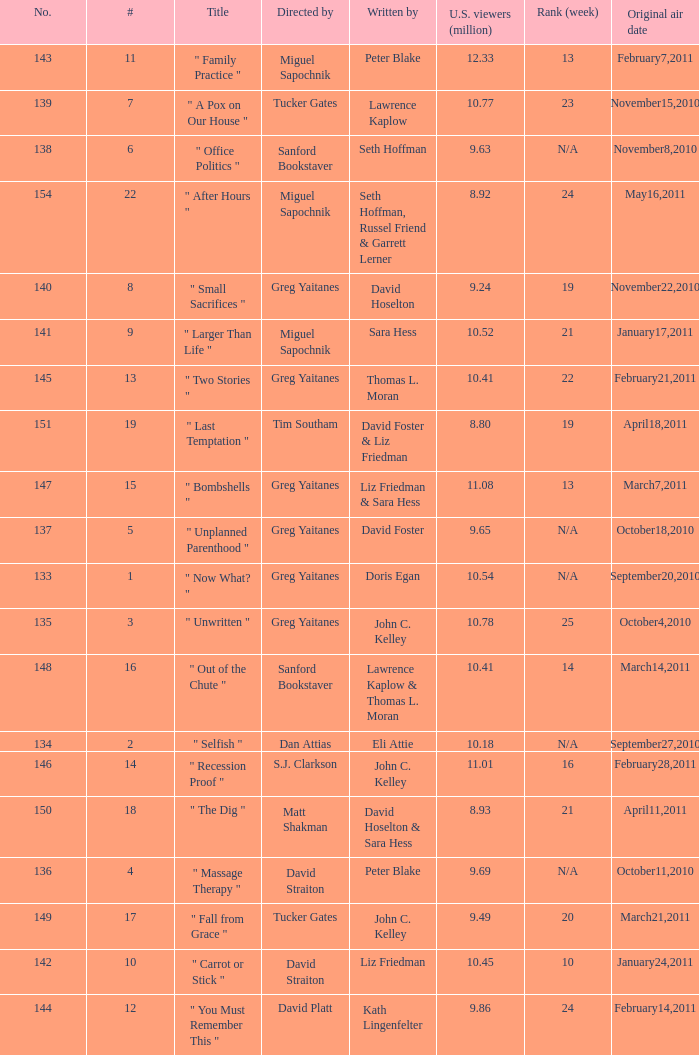How many episodes were written by seth hoffman, russel friend & garrett lerner? 1.0. I'm looking to parse the entire table for insights. Could you assist me with that? {'header': ['No.', '#', 'Title', 'Directed by', 'Written by', 'U.S. viewers (million)', 'Rank (week)', 'Original air date'], 'rows': [['143', '11', '" Family Practice "', 'Miguel Sapochnik', 'Peter Blake', '12.33', '13', 'February7,2011'], ['139', '7', '" A Pox on Our House "', 'Tucker Gates', 'Lawrence Kaplow', '10.77', '23', 'November15,2010'], ['138', '6', '" Office Politics "', 'Sanford Bookstaver', 'Seth Hoffman', '9.63', 'N/A', 'November8,2010'], ['154', '22', '" After Hours "', 'Miguel Sapochnik', 'Seth Hoffman, Russel Friend & Garrett Lerner', '8.92', '24', 'May16,2011'], ['140', '8', '" Small Sacrifices "', 'Greg Yaitanes', 'David Hoselton', '9.24', '19', 'November22,2010'], ['141', '9', '" Larger Than Life "', 'Miguel Sapochnik', 'Sara Hess', '10.52', '21', 'January17,2011'], ['145', '13', '" Two Stories "', 'Greg Yaitanes', 'Thomas L. Moran', '10.41', '22', 'February21,2011'], ['151', '19', '" Last Temptation "', 'Tim Southam', 'David Foster & Liz Friedman', '8.80', '19', 'April18,2011'], ['147', '15', '" Bombshells "', 'Greg Yaitanes', 'Liz Friedman & Sara Hess', '11.08', '13', 'March7,2011'], ['137', '5', '" Unplanned Parenthood "', 'Greg Yaitanes', 'David Foster', '9.65', 'N/A', 'October18,2010'], ['133', '1', '" Now What? "', 'Greg Yaitanes', 'Doris Egan', '10.54', 'N/A', 'September20,2010'], ['135', '3', '" Unwritten "', 'Greg Yaitanes', 'John C. Kelley', '10.78', '25', 'October4,2010'], ['148', '16', '" Out of the Chute "', 'Sanford Bookstaver', 'Lawrence Kaplow & Thomas L. Moran', '10.41', '14', 'March14,2011'], ['134', '2', '" Selfish "', 'Dan Attias', 'Eli Attie', '10.18', 'N/A', 'September27,2010'], ['146', '14', '" Recession Proof "', 'S.J. Clarkson', 'John C. Kelley', '11.01', '16', 'February28,2011'], ['150', '18', '" The Dig "', 'Matt Shakman', 'David Hoselton & Sara Hess', '8.93', '21', 'April11,2011'], ['136', '4', '" Massage Therapy "', 'David Straiton', 'Peter Blake', '9.69', 'N/A', 'October11,2010'], ['149', '17', '" Fall from Grace "', 'Tucker Gates', 'John C. Kelley', '9.49', '20', 'March21,2011'], ['142', '10', '" Carrot or Stick "', 'David Straiton', 'Liz Friedman', '10.45', '10', 'January24,2011'], ['144', '12', '" You Must Remember This "', 'David Platt', 'Kath Lingenfelter', '9.86', '24', 'February14,2011']]} 